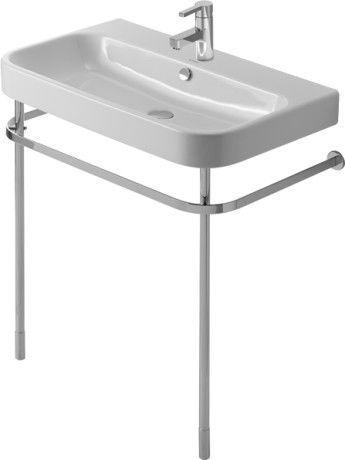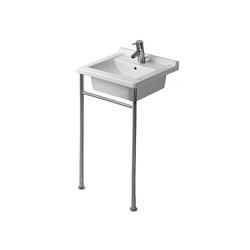The first image is the image on the left, the second image is the image on the right. Analyze the images presented: Is the assertion "One sink is round shaped." valid? Answer yes or no. No. The first image is the image on the left, the second image is the image on the right. For the images displayed, is the sentence "One image shows a rectangular sink supported by two metal legs, with a horizontal bar along three sides." factually correct? Answer yes or no. Yes. 